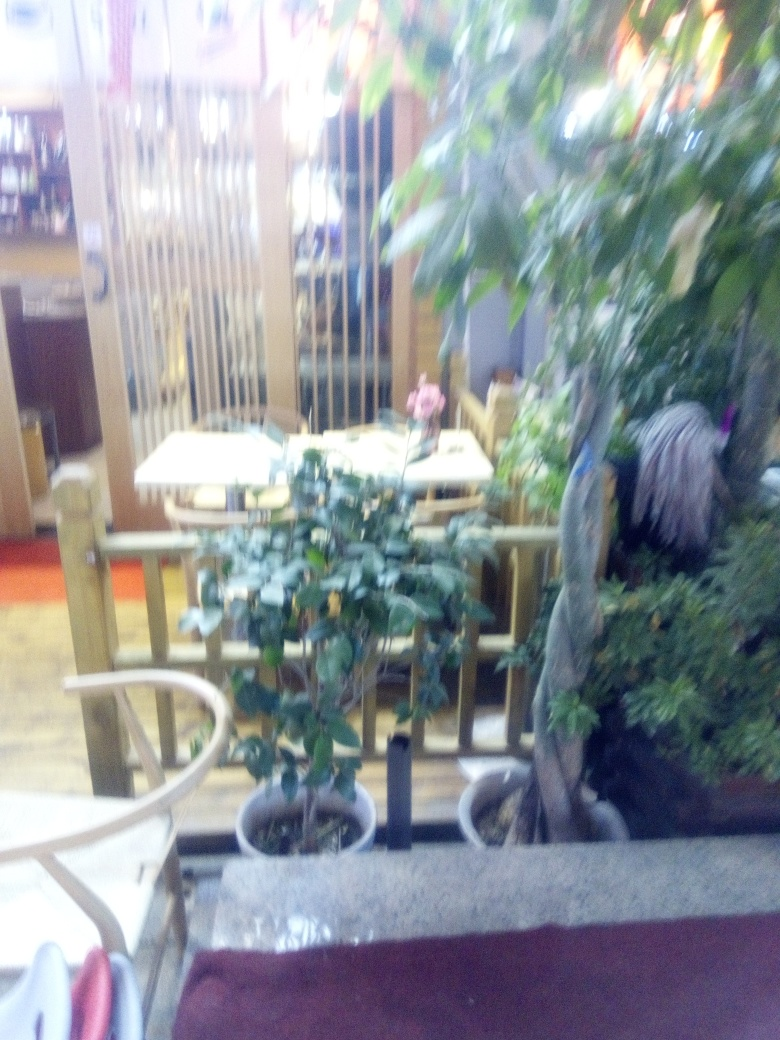Are there any people present in the image? The blurriness of the image makes it challenging to identify people with certainty. However, no clear human figures are discernible in the immediate vicinity of the tables and chairs. 